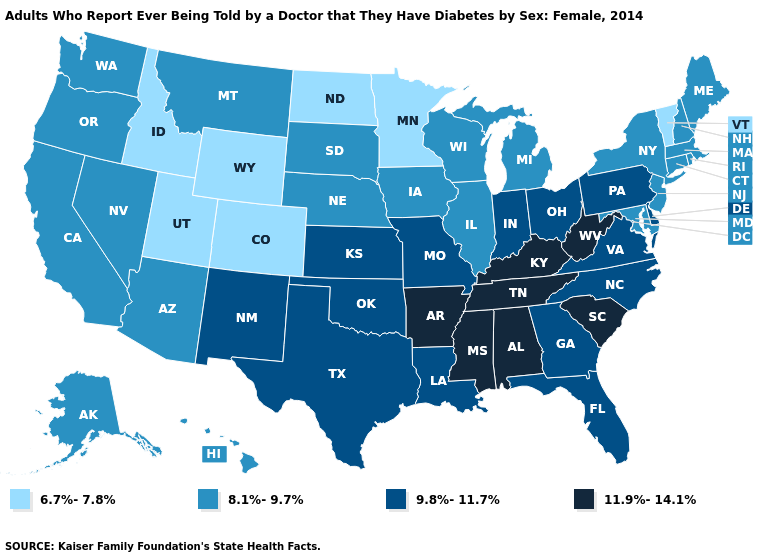Which states hav the highest value in the West?
Short answer required. New Mexico. Does California have a lower value than Idaho?
Write a very short answer. No. Among the states that border Michigan , does Ohio have the highest value?
Concise answer only. Yes. What is the value of Ohio?
Be succinct. 9.8%-11.7%. What is the highest value in the USA?
Answer briefly. 11.9%-14.1%. Name the states that have a value in the range 8.1%-9.7%?
Quick response, please. Alaska, Arizona, California, Connecticut, Hawaii, Illinois, Iowa, Maine, Maryland, Massachusetts, Michigan, Montana, Nebraska, Nevada, New Hampshire, New Jersey, New York, Oregon, Rhode Island, South Dakota, Washington, Wisconsin. Which states have the highest value in the USA?
Give a very brief answer. Alabama, Arkansas, Kentucky, Mississippi, South Carolina, Tennessee, West Virginia. Does South Carolina have a lower value than Mississippi?
Short answer required. No. Which states have the highest value in the USA?
Concise answer only. Alabama, Arkansas, Kentucky, Mississippi, South Carolina, Tennessee, West Virginia. Which states have the lowest value in the West?
Keep it brief. Colorado, Idaho, Utah, Wyoming. Name the states that have a value in the range 9.8%-11.7%?
Be succinct. Delaware, Florida, Georgia, Indiana, Kansas, Louisiana, Missouri, New Mexico, North Carolina, Ohio, Oklahoma, Pennsylvania, Texas, Virginia. What is the value of Connecticut?
Keep it brief. 8.1%-9.7%. What is the highest value in states that border North Dakota?
Keep it brief. 8.1%-9.7%. Among the states that border Delaware , does Pennsylvania have the lowest value?
Answer briefly. No. Name the states that have a value in the range 9.8%-11.7%?
Give a very brief answer. Delaware, Florida, Georgia, Indiana, Kansas, Louisiana, Missouri, New Mexico, North Carolina, Ohio, Oklahoma, Pennsylvania, Texas, Virginia. 